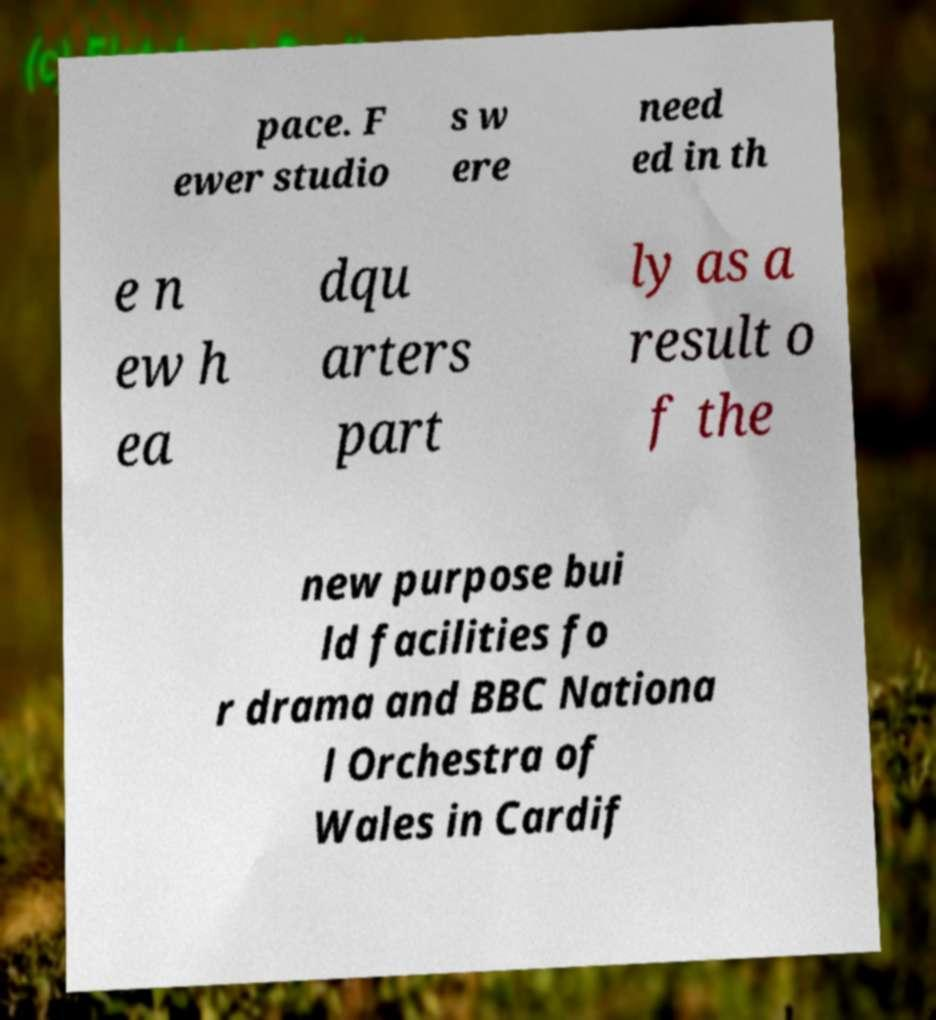I need the written content from this picture converted into text. Can you do that? pace. F ewer studio s w ere need ed in th e n ew h ea dqu arters part ly as a result o f the new purpose bui ld facilities fo r drama and BBC Nationa l Orchestra of Wales in Cardif 